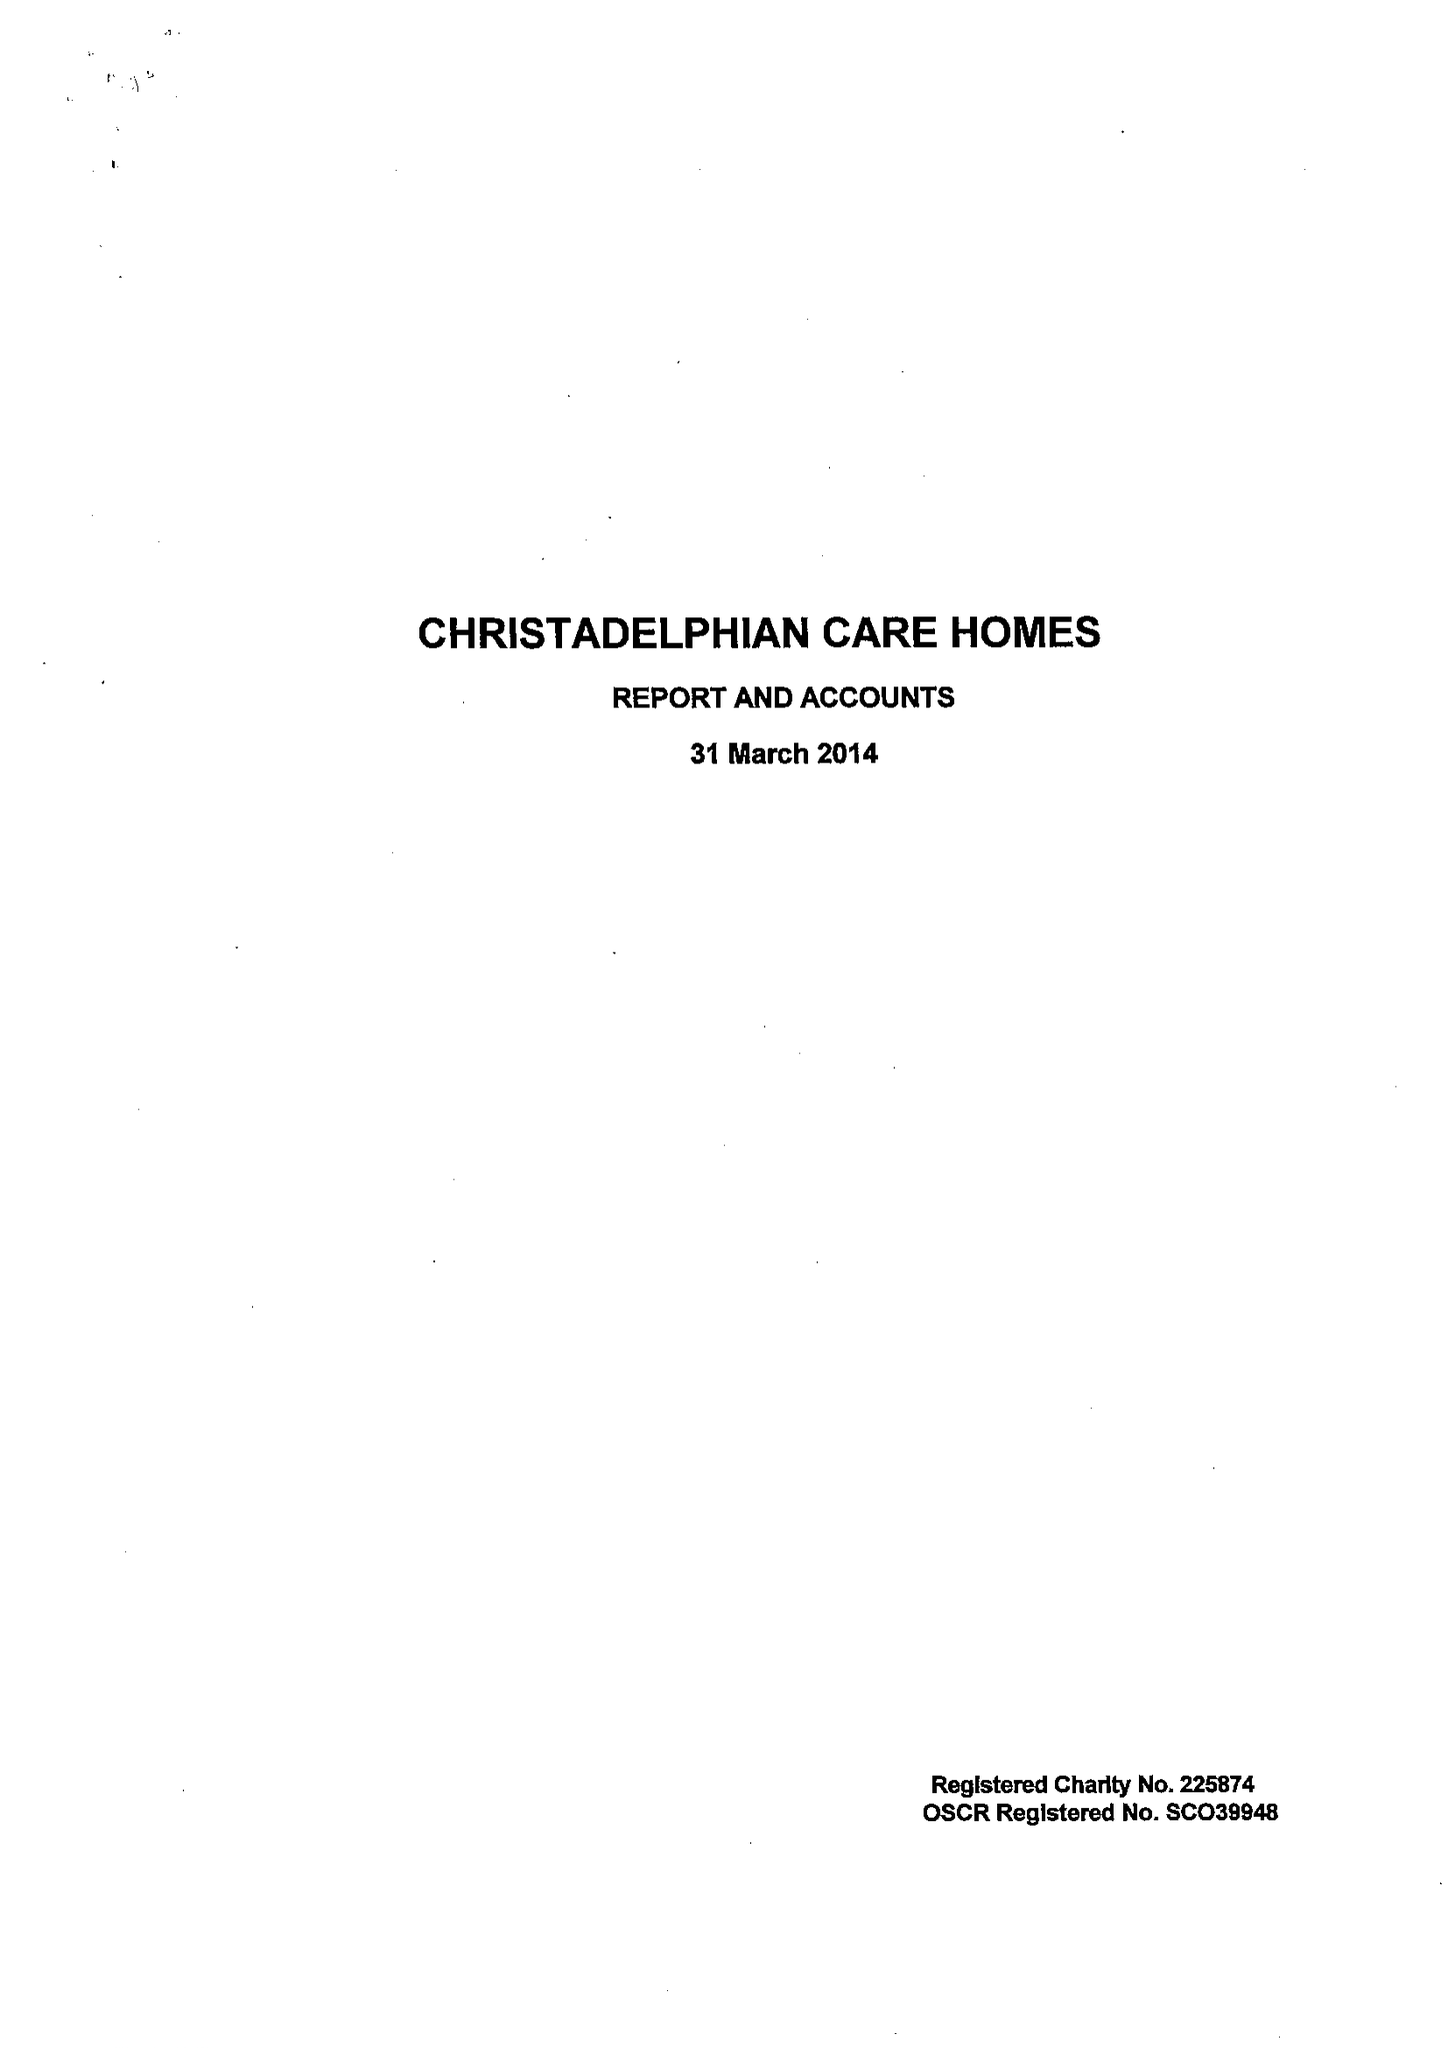What is the value for the charity_number?
Answer the question using a single word or phrase. 225874 